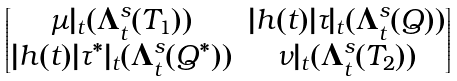Convert formula to latex. <formula><loc_0><loc_0><loc_500><loc_500>\begin{bmatrix} \mu { | _ { t } } ( \Lambda _ { t } ^ { s } ( T _ { 1 } ) ) & | h ( t ) | \tau { | _ { t } } ( \Lambda _ { t } ^ { s } ( Q ) ) \\ | h ( t ) | \tau ^ { * } { | _ { t } } ( \Lambda _ { t } ^ { s } ( Q ^ { * } ) ) & \nu { | _ { t } } ( \Lambda _ { t } ^ { s } ( T _ { 2 } ) ) \end{bmatrix}</formula> 